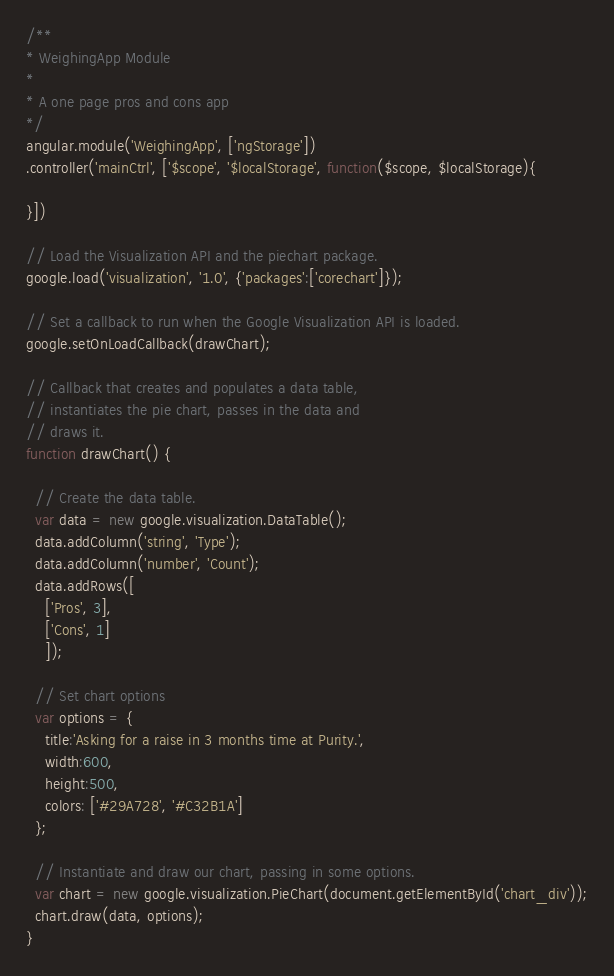<code> <loc_0><loc_0><loc_500><loc_500><_JavaScript_>/**
* WeighingApp Module
*
* A one page pros and cons app
*/
angular.module('WeighingApp', ['ngStorage'])
.controller('mainCtrl', ['$scope', '$localStorage', function($scope, $localStorage){
  
}])

// Load the Visualization API and the piechart package.
google.load('visualization', '1.0', {'packages':['corechart']});

// Set a callback to run when the Google Visualization API is loaded.
google.setOnLoadCallback(drawChart);

// Callback that creates and populates a data table,
// instantiates the pie chart, passes in the data and
// draws it.
function drawChart() {

  // Create the data table.
  var data = new google.visualization.DataTable();
  data.addColumn('string', 'Type');
  data.addColumn('number', 'Count');
  data.addRows([
    ['Pros', 3],
    ['Cons', 1]
    ]);

  // Set chart options
  var options = {
    title:'Asking for a raise in 3 months time at Purity.',
    width:600,
    height:500,
    colors: ['#29A728', '#C32B1A']
  };

  // Instantiate and draw our chart, passing in some options.
  var chart = new google.visualization.PieChart(document.getElementById('chart_div'));
  chart.draw(data, options);
}</code> 